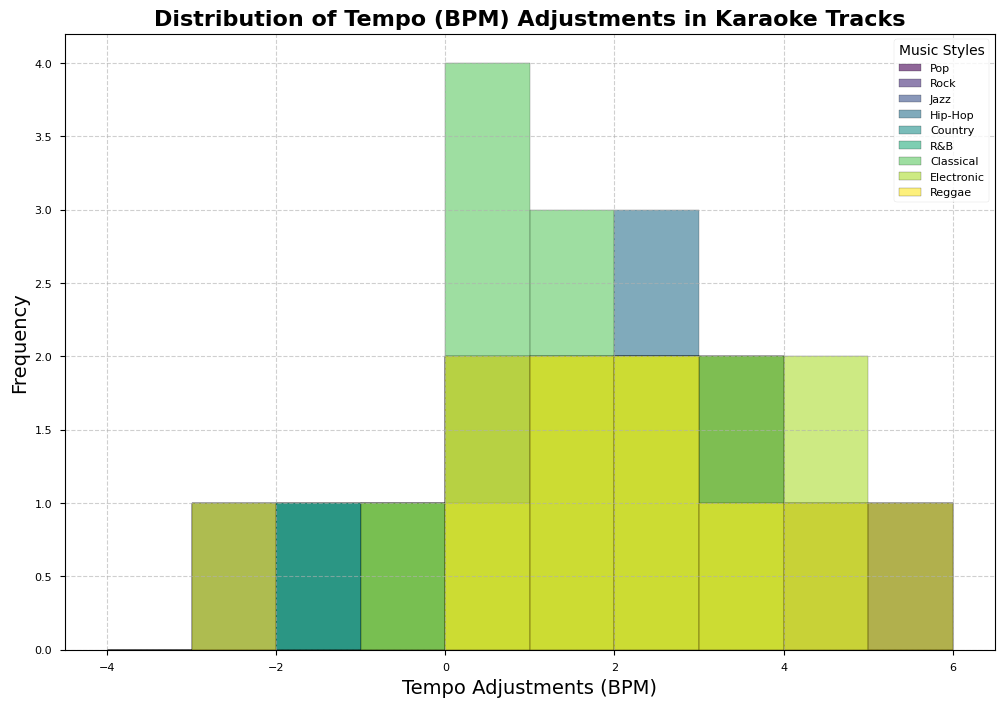Which music style appears to have the most frequent positive tempo adjustments? By observing the histogram, we can see that the most frequent positive tempo adjustments are represented by taller bars. For the Hip-Hop style, there are numerous tall bars in the positive tempo range (particularly around +2 and +3 BPM). Therefore, Hip-Hop has the most frequent positive tempo adjustments.
Answer: Hip-Hop What is the mode of tempo adjustments for Electronic music? The mode is the value that appears most frequently. For Electronic music, the tallest bar, indicating the most frequent value, is around +2 BPM. Hence, the mode for Electronic music's tempo adjustments is +2 BPM.
Answer: +2 BPM Which music style shows the most negative tempo adjustments? We need to look for the style with the highest frequency of negative tempo adjustments. From the histogram, Rock has noticeable negative bars, particularly at -2 BPM and -3 BPM. Hence, Rock shows the most negative tempo adjustments.
Answer: Rock Between Pop and Jazz, which music style exhibits a higher frequency of zero tempo adjustments? A comparison of the height of the bars at 0 BPM for both Pop and Jazz shows that Jazz has more frequent zero tempo adjustments due to the taller bar.
Answer: Jazz Which music style has the most distinct peak at +5 BPM? The distinct peak at +5 BPM is identified by a high frequency at +5 BPM. Observing the histogram, Rock and Reggae both have significant peaks at +5 BPM, but Reggae's peak is slightly more pronounced. Therefore, Reggae has the most distinct peak at +5 BPM.
Answer: Reggae What is the most common range of tempo adjustments for Classical music? The common range can be identified by the highest density of bars in a specific range. For Classical music, most of the histogram bars are between 0 BPM and +2 BPM, showing this is the most common range of adjustments.
Answer: 0 to +2 BPM How does the frequency of +4 BPM adjustments in Pop compare to R&B? To compare, we observe the heights of the bars at +4 BPM. Pop has a high bar around +4 BPM, whereas R&B has no significant bar at +4 BPM. Therefore, Pop has a higher frequency of +4 BPM adjustments compared to R&B.
Answer: Pop What is the most frequent tempo adjustment for Country music? By looking for the tallest bar in Country's histogram segment, we observe that the most frequent tempo adjustments are around +2 BPM. Hence, +2 BPM is the most frequent tempo adjustment in Country music.
Answer: +2 BPM Which music style has a broader spread of tempo adjustments, Hip-Hop or Reggae? By examining the width of the ranges covered by the bars for each genre, Hip-Hop's bars span from approximately 0 to +5 BPM, while Reggae's bars range from around -3 to +5 BPM. Therefore, Reggae has a broader spread of tempo adjustments.
Answer: Reggae 